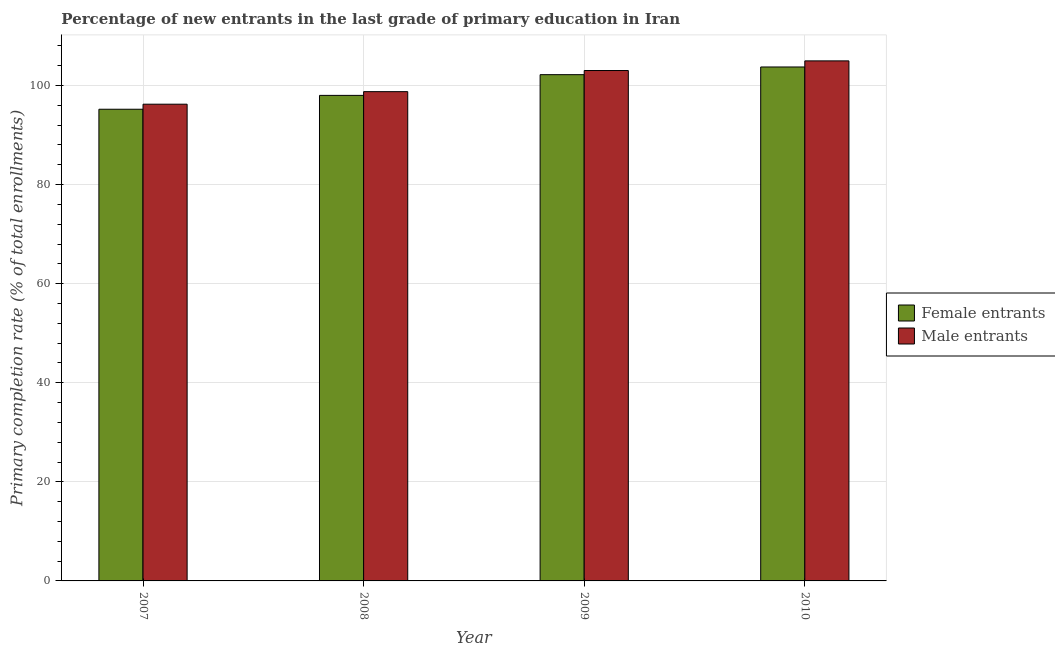How many groups of bars are there?
Provide a succinct answer. 4. How many bars are there on the 4th tick from the left?
Offer a very short reply. 2. In how many cases, is the number of bars for a given year not equal to the number of legend labels?
Ensure brevity in your answer.  0. What is the primary completion rate of male entrants in 2008?
Your answer should be compact. 98.76. Across all years, what is the maximum primary completion rate of female entrants?
Offer a terse response. 103.74. Across all years, what is the minimum primary completion rate of male entrants?
Provide a succinct answer. 96.22. In which year was the primary completion rate of female entrants maximum?
Your answer should be very brief. 2010. What is the total primary completion rate of female entrants in the graph?
Your answer should be very brief. 399.14. What is the difference between the primary completion rate of female entrants in 2009 and that in 2010?
Ensure brevity in your answer.  -1.55. What is the difference between the primary completion rate of male entrants in 2008 and the primary completion rate of female entrants in 2007?
Your answer should be compact. 2.53. What is the average primary completion rate of female entrants per year?
Provide a succinct answer. 99.78. In the year 2010, what is the difference between the primary completion rate of female entrants and primary completion rate of male entrants?
Your answer should be very brief. 0. What is the ratio of the primary completion rate of female entrants in 2007 to that in 2010?
Provide a succinct answer. 0.92. Is the primary completion rate of female entrants in 2009 less than that in 2010?
Keep it short and to the point. Yes. What is the difference between the highest and the second highest primary completion rate of female entrants?
Offer a very short reply. 1.55. What is the difference between the highest and the lowest primary completion rate of female entrants?
Offer a very short reply. 8.53. In how many years, is the primary completion rate of male entrants greater than the average primary completion rate of male entrants taken over all years?
Offer a very short reply. 2. Is the sum of the primary completion rate of male entrants in 2007 and 2008 greater than the maximum primary completion rate of female entrants across all years?
Your answer should be compact. Yes. What does the 2nd bar from the left in 2010 represents?
Your response must be concise. Male entrants. What does the 1st bar from the right in 2008 represents?
Ensure brevity in your answer.  Male entrants. Are all the bars in the graph horizontal?
Ensure brevity in your answer.  No. What is the difference between two consecutive major ticks on the Y-axis?
Provide a succinct answer. 20. Are the values on the major ticks of Y-axis written in scientific E-notation?
Your response must be concise. No. Does the graph contain grids?
Provide a short and direct response. Yes. How are the legend labels stacked?
Your answer should be compact. Vertical. What is the title of the graph?
Make the answer very short. Percentage of new entrants in the last grade of primary education in Iran. Does "Taxes on exports" appear as one of the legend labels in the graph?
Offer a very short reply. No. What is the label or title of the Y-axis?
Your response must be concise. Primary completion rate (% of total enrollments). What is the Primary completion rate (% of total enrollments) of Female entrants in 2007?
Offer a very short reply. 95.21. What is the Primary completion rate (% of total enrollments) in Male entrants in 2007?
Keep it short and to the point. 96.22. What is the Primary completion rate (% of total enrollments) of Female entrants in 2008?
Offer a terse response. 98. What is the Primary completion rate (% of total enrollments) in Male entrants in 2008?
Offer a terse response. 98.76. What is the Primary completion rate (% of total enrollments) in Female entrants in 2009?
Give a very brief answer. 102.19. What is the Primary completion rate (% of total enrollments) of Male entrants in 2009?
Your response must be concise. 103.02. What is the Primary completion rate (% of total enrollments) in Female entrants in 2010?
Your answer should be compact. 103.74. What is the Primary completion rate (% of total enrollments) of Male entrants in 2010?
Your answer should be compact. 104.97. Across all years, what is the maximum Primary completion rate (% of total enrollments) of Female entrants?
Give a very brief answer. 103.74. Across all years, what is the maximum Primary completion rate (% of total enrollments) in Male entrants?
Your answer should be very brief. 104.97. Across all years, what is the minimum Primary completion rate (% of total enrollments) of Female entrants?
Make the answer very short. 95.21. Across all years, what is the minimum Primary completion rate (% of total enrollments) in Male entrants?
Give a very brief answer. 96.22. What is the total Primary completion rate (% of total enrollments) of Female entrants in the graph?
Offer a terse response. 399.14. What is the total Primary completion rate (% of total enrollments) of Male entrants in the graph?
Give a very brief answer. 402.97. What is the difference between the Primary completion rate (% of total enrollments) in Female entrants in 2007 and that in 2008?
Provide a succinct answer. -2.8. What is the difference between the Primary completion rate (% of total enrollments) of Male entrants in 2007 and that in 2008?
Your response must be concise. -2.53. What is the difference between the Primary completion rate (% of total enrollments) of Female entrants in 2007 and that in 2009?
Ensure brevity in your answer.  -6.98. What is the difference between the Primary completion rate (% of total enrollments) of Male entrants in 2007 and that in 2009?
Give a very brief answer. -6.8. What is the difference between the Primary completion rate (% of total enrollments) in Female entrants in 2007 and that in 2010?
Keep it short and to the point. -8.53. What is the difference between the Primary completion rate (% of total enrollments) in Male entrants in 2007 and that in 2010?
Keep it short and to the point. -8.74. What is the difference between the Primary completion rate (% of total enrollments) in Female entrants in 2008 and that in 2009?
Provide a short and direct response. -4.18. What is the difference between the Primary completion rate (% of total enrollments) of Male entrants in 2008 and that in 2009?
Offer a very short reply. -4.26. What is the difference between the Primary completion rate (% of total enrollments) of Female entrants in 2008 and that in 2010?
Provide a succinct answer. -5.73. What is the difference between the Primary completion rate (% of total enrollments) in Male entrants in 2008 and that in 2010?
Offer a very short reply. -6.21. What is the difference between the Primary completion rate (% of total enrollments) in Female entrants in 2009 and that in 2010?
Your answer should be compact. -1.55. What is the difference between the Primary completion rate (% of total enrollments) in Male entrants in 2009 and that in 2010?
Offer a terse response. -1.95. What is the difference between the Primary completion rate (% of total enrollments) of Female entrants in 2007 and the Primary completion rate (% of total enrollments) of Male entrants in 2008?
Provide a short and direct response. -3.55. What is the difference between the Primary completion rate (% of total enrollments) of Female entrants in 2007 and the Primary completion rate (% of total enrollments) of Male entrants in 2009?
Provide a short and direct response. -7.82. What is the difference between the Primary completion rate (% of total enrollments) in Female entrants in 2007 and the Primary completion rate (% of total enrollments) in Male entrants in 2010?
Keep it short and to the point. -9.76. What is the difference between the Primary completion rate (% of total enrollments) in Female entrants in 2008 and the Primary completion rate (% of total enrollments) in Male entrants in 2009?
Provide a short and direct response. -5.02. What is the difference between the Primary completion rate (% of total enrollments) of Female entrants in 2008 and the Primary completion rate (% of total enrollments) of Male entrants in 2010?
Give a very brief answer. -6.96. What is the difference between the Primary completion rate (% of total enrollments) in Female entrants in 2009 and the Primary completion rate (% of total enrollments) in Male entrants in 2010?
Your answer should be very brief. -2.78. What is the average Primary completion rate (% of total enrollments) in Female entrants per year?
Offer a very short reply. 99.78. What is the average Primary completion rate (% of total enrollments) in Male entrants per year?
Make the answer very short. 100.74. In the year 2007, what is the difference between the Primary completion rate (% of total enrollments) of Female entrants and Primary completion rate (% of total enrollments) of Male entrants?
Your response must be concise. -1.02. In the year 2008, what is the difference between the Primary completion rate (% of total enrollments) in Female entrants and Primary completion rate (% of total enrollments) in Male entrants?
Give a very brief answer. -0.75. In the year 2009, what is the difference between the Primary completion rate (% of total enrollments) of Female entrants and Primary completion rate (% of total enrollments) of Male entrants?
Offer a very short reply. -0.83. In the year 2010, what is the difference between the Primary completion rate (% of total enrollments) in Female entrants and Primary completion rate (% of total enrollments) in Male entrants?
Provide a short and direct response. -1.23. What is the ratio of the Primary completion rate (% of total enrollments) of Female entrants in 2007 to that in 2008?
Make the answer very short. 0.97. What is the ratio of the Primary completion rate (% of total enrollments) of Male entrants in 2007 to that in 2008?
Your answer should be very brief. 0.97. What is the ratio of the Primary completion rate (% of total enrollments) of Female entrants in 2007 to that in 2009?
Ensure brevity in your answer.  0.93. What is the ratio of the Primary completion rate (% of total enrollments) of Male entrants in 2007 to that in 2009?
Make the answer very short. 0.93. What is the ratio of the Primary completion rate (% of total enrollments) in Female entrants in 2007 to that in 2010?
Your answer should be compact. 0.92. What is the ratio of the Primary completion rate (% of total enrollments) in Male entrants in 2007 to that in 2010?
Keep it short and to the point. 0.92. What is the ratio of the Primary completion rate (% of total enrollments) in Female entrants in 2008 to that in 2009?
Your response must be concise. 0.96. What is the ratio of the Primary completion rate (% of total enrollments) in Male entrants in 2008 to that in 2009?
Your answer should be compact. 0.96. What is the ratio of the Primary completion rate (% of total enrollments) in Female entrants in 2008 to that in 2010?
Offer a terse response. 0.94. What is the ratio of the Primary completion rate (% of total enrollments) of Male entrants in 2008 to that in 2010?
Make the answer very short. 0.94. What is the ratio of the Primary completion rate (% of total enrollments) of Female entrants in 2009 to that in 2010?
Provide a succinct answer. 0.99. What is the ratio of the Primary completion rate (% of total enrollments) in Male entrants in 2009 to that in 2010?
Your response must be concise. 0.98. What is the difference between the highest and the second highest Primary completion rate (% of total enrollments) of Female entrants?
Provide a succinct answer. 1.55. What is the difference between the highest and the second highest Primary completion rate (% of total enrollments) in Male entrants?
Make the answer very short. 1.95. What is the difference between the highest and the lowest Primary completion rate (% of total enrollments) in Female entrants?
Your response must be concise. 8.53. What is the difference between the highest and the lowest Primary completion rate (% of total enrollments) of Male entrants?
Give a very brief answer. 8.74. 